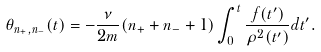<formula> <loc_0><loc_0><loc_500><loc_500>\theta _ { n _ { + } , n _ { - } } ( t ) = - \frac { \nu } { 2 m } ( n _ { + } + n _ { - } + 1 ) \int _ { 0 } ^ { t } \frac { f ( t ^ { \prime } ) } { \rho ^ { 2 } ( t ^ { \prime } ) } d t ^ { \prime } .</formula> 